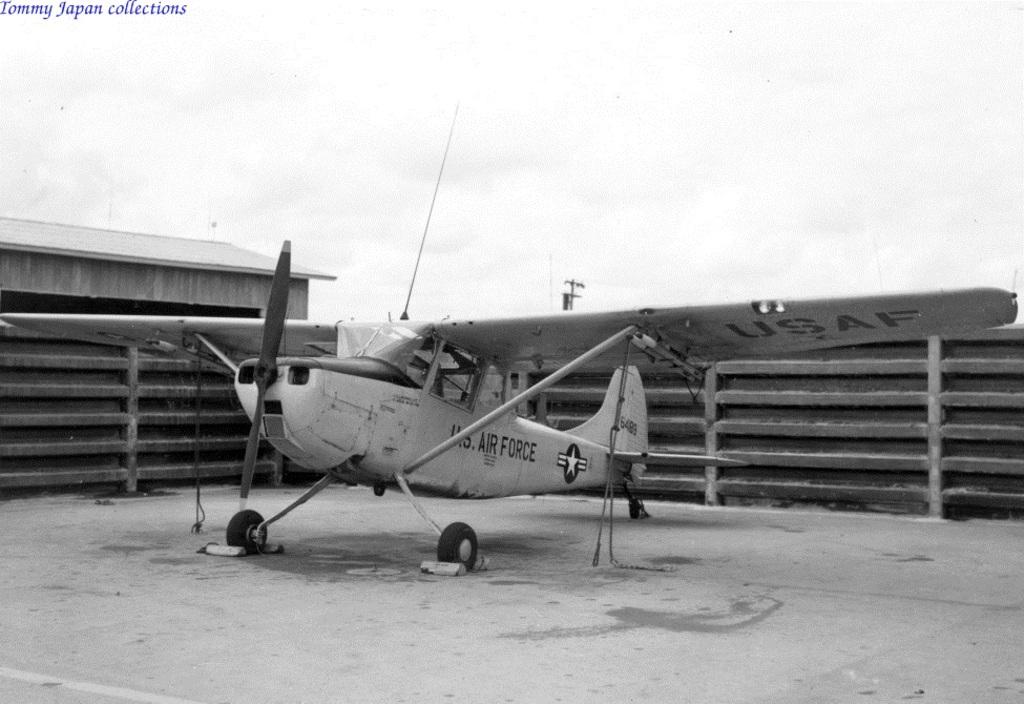What branch of service does this plane belong to?
Ensure brevity in your answer.  U.s. air force. What acronym is displayed on the underside of the wings?
Keep it short and to the point. Usaf. 